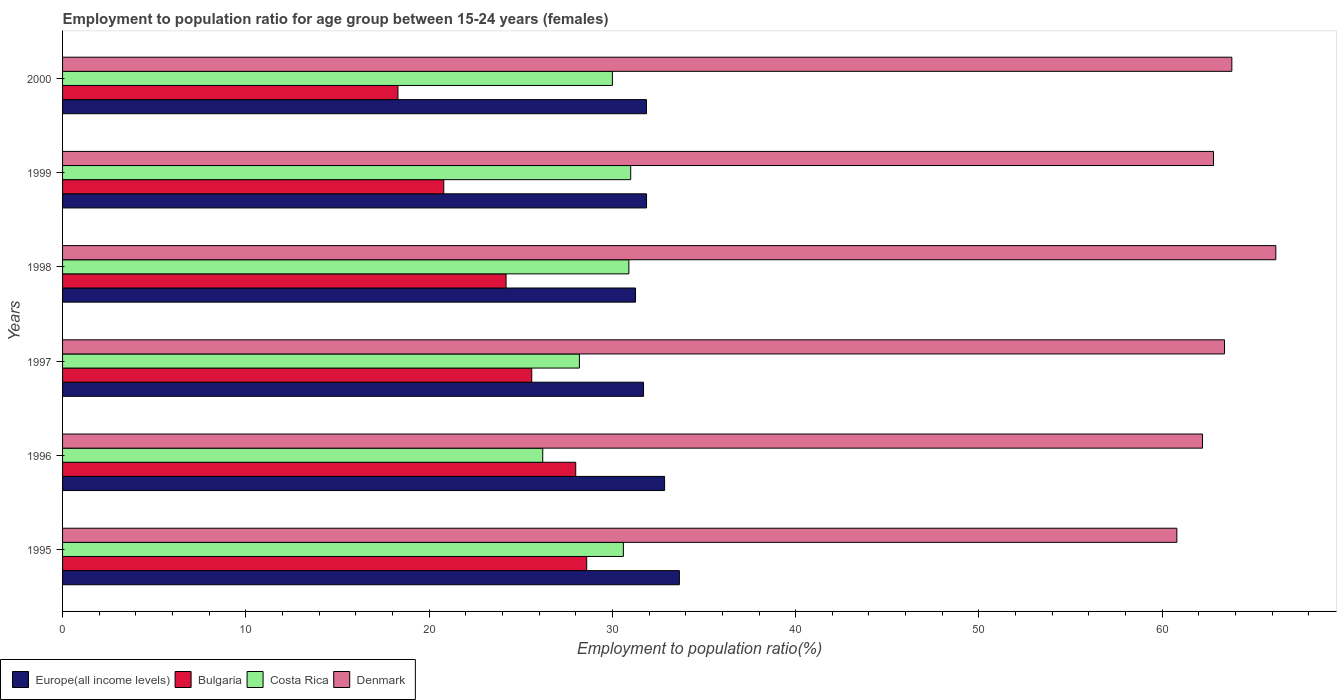How many different coloured bars are there?
Provide a short and direct response. 4. How many groups of bars are there?
Provide a succinct answer. 6. How many bars are there on the 5th tick from the top?
Your answer should be very brief. 4. How many bars are there on the 1st tick from the bottom?
Provide a succinct answer. 4. What is the label of the 2nd group of bars from the top?
Make the answer very short. 1999. In how many cases, is the number of bars for a given year not equal to the number of legend labels?
Your answer should be very brief. 0. What is the employment to population ratio in Bulgaria in 1999?
Offer a terse response. 20.8. Across all years, what is the maximum employment to population ratio in Denmark?
Ensure brevity in your answer.  66.2. Across all years, what is the minimum employment to population ratio in Europe(all income levels)?
Your answer should be compact. 31.26. In which year was the employment to population ratio in Bulgaria maximum?
Give a very brief answer. 1995. In which year was the employment to population ratio in Denmark minimum?
Keep it short and to the point. 1995. What is the total employment to population ratio in Denmark in the graph?
Your answer should be compact. 379.2. What is the difference between the employment to population ratio in Denmark in 1995 and that in 1997?
Give a very brief answer. -2.6. What is the difference between the employment to population ratio in Costa Rica in 1996 and the employment to population ratio in Denmark in 1999?
Give a very brief answer. -36.6. What is the average employment to population ratio in Bulgaria per year?
Your answer should be very brief. 24.25. In the year 1999, what is the difference between the employment to population ratio in Europe(all income levels) and employment to population ratio in Denmark?
Your response must be concise. -30.94. In how many years, is the employment to population ratio in Europe(all income levels) greater than 28 %?
Provide a succinct answer. 6. What is the ratio of the employment to population ratio in Bulgaria in 1995 to that in 2000?
Make the answer very short. 1.56. Is the employment to population ratio in Bulgaria in 1996 less than that in 1999?
Provide a succinct answer. No. Is the difference between the employment to population ratio in Europe(all income levels) in 1995 and 2000 greater than the difference between the employment to population ratio in Denmark in 1995 and 2000?
Your answer should be compact. Yes. What is the difference between the highest and the second highest employment to population ratio in Denmark?
Offer a very short reply. 2.4. What is the difference between the highest and the lowest employment to population ratio in Bulgaria?
Give a very brief answer. 10.3. In how many years, is the employment to population ratio in Europe(all income levels) greater than the average employment to population ratio in Europe(all income levels) taken over all years?
Give a very brief answer. 2. Is the sum of the employment to population ratio in Europe(all income levels) in 1996 and 1998 greater than the maximum employment to population ratio in Denmark across all years?
Provide a short and direct response. No. What does the 4th bar from the top in 1997 represents?
Provide a short and direct response. Europe(all income levels). What does the 1st bar from the bottom in 1995 represents?
Provide a succinct answer. Europe(all income levels). Is it the case that in every year, the sum of the employment to population ratio in Costa Rica and employment to population ratio in Europe(all income levels) is greater than the employment to population ratio in Denmark?
Offer a terse response. No. Are all the bars in the graph horizontal?
Give a very brief answer. Yes. How many years are there in the graph?
Make the answer very short. 6. Does the graph contain any zero values?
Offer a very short reply. No. Does the graph contain grids?
Your answer should be very brief. No. Where does the legend appear in the graph?
Provide a short and direct response. Bottom left. How are the legend labels stacked?
Make the answer very short. Horizontal. What is the title of the graph?
Provide a short and direct response. Employment to population ratio for age group between 15-24 years (females). Does "Sub-Saharan Africa (developing only)" appear as one of the legend labels in the graph?
Ensure brevity in your answer.  No. What is the label or title of the Y-axis?
Give a very brief answer. Years. What is the Employment to population ratio(%) of Europe(all income levels) in 1995?
Keep it short and to the point. 33.66. What is the Employment to population ratio(%) of Bulgaria in 1995?
Your answer should be compact. 28.6. What is the Employment to population ratio(%) of Costa Rica in 1995?
Offer a very short reply. 30.6. What is the Employment to population ratio(%) of Denmark in 1995?
Your answer should be very brief. 60.8. What is the Employment to population ratio(%) in Europe(all income levels) in 1996?
Keep it short and to the point. 32.85. What is the Employment to population ratio(%) in Costa Rica in 1996?
Your answer should be very brief. 26.2. What is the Employment to population ratio(%) of Denmark in 1996?
Keep it short and to the point. 62.2. What is the Employment to population ratio(%) in Europe(all income levels) in 1997?
Offer a very short reply. 31.7. What is the Employment to population ratio(%) in Bulgaria in 1997?
Your response must be concise. 25.6. What is the Employment to population ratio(%) of Costa Rica in 1997?
Give a very brief answer. 28.2. What is the Employment to population ratio(%) of Denmark in 1997?
Give a very brief answer. 63.4. What is the Employment to population ratio(%) of Europe(all income levels) in 1998?
Offer a very short reply. 31.26. What is the Employment to population ratio(%) in Bulgaria in 1998?
Provide a succinct answer. 24.2. What is the Employment to population ratio(%) in Costa Rica in 1998?
Provide a succinct answer. 30.9. What is the Employment to population ratio(%) in Denmark in 1998?
Provide a succinct answer. 66.2. What is the Employment to population ratio(%) of Europe(all income levels) in 1999?
Offer a terse response. 31.86. What is the Employment to population ratio(%) in Bulgaria in 1999?
Make the answer very short. 20.8. What is the Employment to population ratio(%) in Denmark in 1999?
Your response must be concise. 62.8. What is the Employment to population ratio(%) in Europe(all income levels) in 2000?
Provide a short and direct response. 31.86. What is the Employment to population ratio(%) of Bulgaria in 2000?
Provide a short and direct response. 18.3. What is the Employment to population ratio(%) in Denmark in 2000?
Ensure brevity in your answer.  63.8. Across all years, what is the maximum Employment to population ratio(%) of Europe(all income levels)?
Keep it short and to the point. 33.66. Across all years, what is the maximum Employment to population ratio(%) of Bulgaria?
Make the answer very short. 28.6. Across all years, what is the maximum Employment to population ratio(%) of Costa Rica?
Provide a succinct answer. 31. Across all years, what is the maximum Employment to population ratio(%) in Denmark?
Provide a succinct answer. 66.2. Across all years, what is the minimum Employment to population ratio(%) of Europe(all income levels)?
Your answer should be compact. 31.26. Across all years, what is the minimum Employment to population ratio(%) of Bulgaria?
Give a very brief answer. 18.3. Across all years, what is the minimum Employment to population ratio(%) of Costa Rica?
Offer a terse response. 26.2. Across all years, what is the minimum Employment to population ratio(%) in Denmark?
Your answer should be very brief. 60.8. What is the total Employment to population ratio(%) in Europe(all income levels) in the graph?
Ensure brevity in your answer.  193.19. What is the total Employment to population ratio(%) in Bulgaria in the graph?
Give a very brief answer. 145.5. What is the total Employment to population ratio(%) in Costa Rica in the graph?
Give a very brief answer. 176.9. What is the total Employment to population ratio(%) of Denmark in the graph?
Offer a terse response. 379.2. What is the difference between the Employment to population ratio(%) in Europe(all income levels) in 1995 and that in 1996?
Keep it short and to the point. 0.81. What is the difference between the Employment to population ratio(%) of Costa Rica in 1995 and that in 1996?
Make the answer very short. 4.4. What is the difference between the Employment to population ratio(%) of Europe(all income levels) in 1995 and that in 1997?
Provide a succinct answer. 1.96. What is the difference between the Employment to population ratio(%) in Bulgaria in 1995 and that in 1997?
Your answer should be compact. 3. What is the difference between the Employment to population ratio(%) of Costa Rica in 1995 and that in 1997?
Your answer should be very brief. 2.4. What is the difference between the Employment to population ratio(%) in Europe(all income levels) in 1995 and that in 1998?
Ensure brevity in your answer.  2.39. What is the difference between the Employment to population ratio(%) in Bulgaria in 1995 and that in 1998?
Offer a terse response. 4.4. What is the difference between the Employment to population ratio(%) in Costa Rica in 1995 and that in 1998?
Make the answer very short. -0.3. What is the difference between the Employment to population ratio(%) in Europe(all income levels) in 1995 and that in 1999?
Keep it short and to the point. 1.79. What is the difference between the Employment to population ratio(%) of Bulgaria in 1995 and that in 1999?
Your response must be concise. 7.8. What is the difference between the Employment to population ratio(%) in Costa Rica in 1995 and that in 1999?
Ensure brevity in your answer.  -0.4. What is the difference between the Employment to population ratio(%) in Europe(all income levels) in 1995 and that in 2000?
Make the answer very short. 1.8. What is the difference between the Employment to population ratio(%) of Bulgaria in 1995 and that in 2000?
Give a very brief answer. 10.3. What is the difference between the Employment to population ratio(%) of Denmark in 1995 and that in 2000?
Ensure brevity in your answer.  -3. What is the difference between the Employment to population ratio(%) in Europe(all income levels) in 1996 and that in 1997?
Your answer should be very brief. 1.15. What is the difference between the Employment to population ratio(%) of Europe(all income levels) in 1996 and that in 1998?
Keep it short and to the point. 1.59. What is the difference between the Employment to population ratio(%) of Bulgaria in 1996 and that in 1998?
Your answer should be very brief. 3.8. What is the difference between the Employment to population ratio(%) of Denmark in 1996 and that in 1998?
Your answer should be compact. -4. What is the difference between the Employment to population ratio(%) in Europe(all income levels) in 1996 and that in 1999?
Ensure brevity in your answer.  0.98. What is the difference between the Employment to population ratio(%) of Bulgaria in 1996 and that in 1999?
Ensure brevity in your answer.  7.2. What is the difference between the Employment to population ratio(%) of Costa Rica in 1996 and that in 1999?
Your answer should be compact. -4.8. What is the difference between the Employment to population ratio(%) in Europe(all income levels) in 1996 and that in 2000?
Ensure brevity in your answer.  0.99. What is the difference between the Employment to population ratio(%) in Europe(all income levels) in 1997 and that in 1998?
Keep it short and to the point. 0.44. What is the difference between the Employment to population ratio(%) of Europe(all income levels) in 1997 and that in 1999?
Offer a very short reply. -0.17. What is the difference between the Employment to population ratio(%) in Bulgaria in 1997 and that in 1999?
Your response must be concise. 4.8. What is the difference between the Employment to population ratio(%) of Costa Rica in 1997 and that in 1999?
Your response must be concise. -2.8. What is the difference between the Employment to population ratio(%) of Denmark in 1997 and that in 1999?
Provide a succinct answer. 0.6. What is the difference between the Employment to population ratio(%) of Europe(all income levels) in 1997 and that in 2000?
Make the answer very short. -0.16. What is the difference between the Employment to population ratio(%) of Costa Rica in 1997 and that in 2000?
Ensure brevity in your answer.  -1.8. What is the difference between the Employment to population ratio(%) in Europe(all income levels) in 1998 and that in 1999?
Give a very brief answer. -0.6. What is the difference between the Employment to population ratio(%) of Bulgaria in 1998 and that in 1999?
Provide a succinct answer. 3.4. What is the difference between the Employment to population ratio(%) of Denmark in 1998 and that in 1999?
Your response must be concise. 3.4. What is the difference between the Employment to population ratio(%) of Europe(all income levels) in 1998 and that in 2000?
Ensure brevity in your answer.  -0.6. What is the difference between the Employment to population ratio(%) of Bulgaria in 1998 and that in 2000?
Ensure brevity in your answer.  5.9. What is the difference between the Employment to population ratio(%) of Costa Rica in 1998 and that in 2000?
Offer a very short reply. 0.9. What is the difference between the Employment to population ratio(%) in Denmark in 1998 and that in 2000?
Ensure brevity in your answer.  2.4. What is the difference between the Employment to population ratio(%) of Europe(all income levels) in 1999 and that in 2000?
Your response must be concise. 0. What is the difference between the Employment to population ratio(%) of Bulgaria in 1999 and that in 2000?
Offer a very short reply. 2.5. What is the difference between the Employment to population ratio(%) of Costa Rica in 1999 and that in 2000?
Offer a very short reply. 1. What is the difference between the Employment to population ratio(%) of Denmark in 1999 and that in 2000?
Make the answer very short. -1. What is the difference between the Employment to population ratio(%) in Europe(all income levels) in 1995 and the Employment to population ratio(%) in Bulgaria in 1996?
Your response must be concise. 5.66. What is the difference between the Employment to population ratio(%) in Europe(all income levels) in 1995 and the Employment to population ratio(%) in Costa Rica in 1996?
Your response must be concise. 7.46. What is the difference between the Employment to population ratio(%) of Europe(all income levels) in 1995 and the Employment to population ratio(%) of Denmark in 1996?
Give a very brief answer. -28.55. What is the difference between the Employment to population ratio(%) in Bulgaria in 1995 and the Employment to population ratio(%) in Denmark in 1996?
Keep it short and to the point. -33.6. What is the difference between the Employment to population ratio(%) in Costa Rica in 1995 and the Employment to population ratio(%) in Denmark in 1996?
Your response must be concise. -31.6. What is the difference between the Employment to population ratio(%) in Europe(all income levels) in 1995 and the Employment to population ratio(%) in Bulgaria in 1997?
Your answer should be very brief. 8.05. What is the difference between the Employment to population ratio(%) in Europe(all income levels) in 1995 and the Employment to population ratio(%) in Costa Rica in 1997?
Your answer should be compact. 5.46. What is the difference between the Employment to population ratio(%) of Europe(all income levels) in 1995 and the Employment to population ratio(%) of Denmark in 1997?
Keep it short and to the point. -29.75. What is the difference between the Employment to population ratio(%) of Bulgaria in 1995 and the Employment to population ratio(%) of Denmark in 1997?
Offer a terse response. -34.8. What is the difference between the Employment to population ratio(%) in Costa Rica in 1995 and the Employment to population ratio(%) in Denmark in 1997?
Offer a very short reply. -32.8. What is the difference between the Employment to population ratio(%) of Europe(all income levels) in 1995 and the Employment to population ratio(%) of Bulgaria in 1998?
Your response must be concise. 9.46. What is the difference between the Employment to population ratio(%) in Europe(all income levels) in 1995 and the Employment to population ratio(%) in Costa Rica in 1998?
Keep it short and to the point. 2.75. What is the difference between the Employment to population ratio(%) in Europe(all income levels) in 1995 and the Employment to population ratio(%) in Denmark in 1998?
Give a very brief answer. -32.55. What is the difference between the Employment to population ratio(%) of Bulgaria in 1995 and the Employment to population ratio(%) of Costa Rica in 1998?
Offer a terse response. -2.3. What is the difference between the Employment to population ratio(%) in Bulgaria in 1995 and the Employment to population ratio(%) in Denmark in 1998?
Ensure brevity in your answer.  -37.6. What is the difference between the Employment to population ratio(%) of Costa Rica in 1995 and the Employment to population ratio(%) of Denmark in 1998?
Offer a terse response. -35.6. What is the difference between the Employment to population ratio(%) in Europe(all income levels) in 1995 and the Employment to population ratio(%) in Bulgaria in 1999?
Give a very brief answer. 12.86. What is the difference between the Employment to population ratio(%) in Europe(all income levels) in 1995 and the Employment to population ratio(%) in Costa Rica in 1999?
Your answer should be very brief. 2.65. What is the difference between the Employment to population ratio(%) in Europe(all income levels) in 1995 and the Employment to population ratio(%) in Denmark in 1999?
Provide a short and direct response. -29.14. What is the difference between the Employment to population ratio(%) in Bulgaria in 1995 and the Employment to population ratio(%) in Denmark in 1999?
Ensure brevity in your answer.  -34.2. What is the difference between the Employment to population ratio(%) of Costa Rica in 1995 and the Employment to population ratio(%) of Denmark in 1999?
Your answer should be very brief. -32.2. What is the difference between the Employment to population ratio(%) in Europe(all income levels) in 1995 and the Employment to population ratio(%) in Bulgaria in 2000?
Keep it short and to the point. 15.36. What is the difference between the Employment to population ratio(%) of Europe(all income levels) in 1995 and the Employment to population ratio(%) of Costa Rica in 2000?
Your response must be concise. 3.65. What is the difference between the Employment to population ratio(%) of Europe(all income levels) in 1995 and the Employment to population ratio(%) of Denmark in 2000?
Make the answer very short. -30.14. What is the difference between the Employment to population ratio(%) in Bulgaria in 1995 and the Employment to population ratio(%) in Denmark in 2000?
Ensure brevity in your answer.  -35.2. What is the difference between the Employment to population ratio(%) of Costa Rica in 1995 and the Employment to population ratio(%) of Denmark in 2000?
Your answer should be compact. -33.2. What is the difference between the Employment to population ratio(%) of Europe(all income levels) in 1996 and the Employment to population ratio(%) of Bulgaria in 1997?
Give a very brief answer. 7.25. What is the difference between the Employment to population ratio(%) of Europe(all income levels) in 1996 and the Employment to population ratio(%) of Costa Rica in 1997?
Your answer should be compact. 4.65. What is the difference between the Employment to population ratio(%) of Europe(all income levels) in 1996 and the Employment to population ratio(%) of Denmark in 1997?
Your response must be concise. -30.55. What is the difference between the Employment to population ratio(%) of Bulgaria in 1996 and the Employment to population ratio(%) of Costa Rica in 1997?
Keep it short and to the point. -0.2. What is the difference between the Employment to population ratio(%) in Bulgaria in 1996 and the Employment to population ratio(%) in Denmark in 1997?
Make the answer very short. -35.4. What is the difference between the Employment to population ratio(%) of Costa Rica in 1996 and the Employment to population ratio(%) of Denmark in 1997?
Give a very brief answer. -37.2. What is the difference between the Employment to population ratio(%) in Europe(all income levels) in 1996 and the Employment to population ratio(%) in Bulgaria in 1998?
Make the answer very short. 8.65. What is the difference between the Employment to population ratio(%) of Europe(all income levels) in 1996 and the Employment to population ratio(%) of Costa Rica in 1998?
Your response must be concise. 1.95. What is the difference between the Employment to population ratio(%) of Europe(all income levels) in 1996 and the Employment to population ratio(%) of Denmark in 1998?
Provide a succinct answer. -33.35. What is the difference between the Employment to population ratio(%) of Bulgaria in 1996 and the Employment to population ratio(%) of Costa Rica in 1998?
Your response must be concise. -2.9. What is the difference between the Employment to population ratio(%) in Bulgaria in 1996 and the Employment to population ratio(%) in Denmark in 1998?
Provide a short and direct response. -38.2. What is the difference between the Employment to population ratio(%) in Europe(all income levels) in 1996 and the Employment to population ratio(%) in Bulgaria in 1999?
Offer a very short reply. 12.05. What is the difference between the Employment to population ratio(%) of Europe(all income levels) in 1996 and the Employment to population ratio(%) of Costa Rica in 1999?
Offer a terse response. 1.85. What is the difference between the Employment to population ratio(%) in Europe(all income levels) in 1996 and the Employment to population ratio(%) in Denmark in 1999?
Offer a very short reply. -29.95. What is the difference between the Employment to population ratio(%) of Bulgaria in 1996 and the Employment to population ratio(%) of Costa Rica in 1999?
Keep it short and to the point. -3. What is the difference between the Employment to population ratio(%) in Bulgaria in 1996 and the Employment to population ratio(%) in Denmark in 1999?
Ensure brevity in your answer.  -34.8. What is the difference between the Employment to population ratio(%) of Costa Rica in 1996 and the Employment to population ratio(%) of Denmark in 1999?
Your response must be concise. -36.6. What is the difference between the Employment to population ratio(%) of Europe(all income levels) in 1996 and the Employment to population ratio(%) of Bulgaria in 2000?
Your response must be concise. 14.55. What is the difference between the Employment to population ratio(%) in Europe(all income levels) in 1996 and the Employment to population ratio(%) in Costa Rica in 2000?
Provide a succinct answer. 2.85. What is the difference between the Employment to population ratio(%) in Europe(all income levels) in 1996 and the Employment to population ratio(%) in Denmark in 2000?
Your response must be concise. -30.95. What is the difference between the Employment to population ratio(%) in Bulgaria in 1996 and the Employment to population ratio(%) in Denmark in 2000?
Your answer should be compact. -35.8. What is the difference between the Employment to population ratio(%) of Costa Rica in 1996 and the Employment to population ratio(%) of Denmark in 2000?
Make the answer very short. -37.6. What is the difference between the Employment to population ratio(%) in Europe(all income levels) in 1997 and the Employment to population ratio(%) in Bulgaria in 1998?
Provide a succinct answer. 7.5. What is the difference between the Employment to population ratio(%) of Europe(all income levels) in 1997 and the Employment to population ratio(%) of Costa Rica in 1998?
Offer a terse response. 0.8. What is the difference between the Employment to population ratio(%) in Europe(all income levels) in 1997 and the Employment to population ratio(%) in Denmark in 1998?
Give a very brief answer. -34.5. What is the difference between the Employment to population ratio(%) of Bulgaria in 1997 and the Employment to population ratio(%) of Costa Rica in 1998?
Ensure brevity in your answer.  -5.3. What is the difference between the Employment to population ratio(%) of Bulgaria in 1997 and the Employment to population ratio(%) of Denmark in 1998?
Offer a very short reply. -40.6. What is the difference between the Employment to population ratio(%) in Costa Rica in 1997 and the Employment to population ratio(%) in Denmark in 1998?
Offer a very short reply. -38. What is the difference between the Employment to population ratio(%) of Europe(all income levels) in 1997 and the Employment to population ratio(%) of Bulgaria in 1999?
Give a very brief answer. 10.9. What is the difference between the Employment to population ratio(%) in Europe(all income levels) in 1997 and the Employment to population ratio(%) in Costa Rica in 1999?
Provide a succinct answer. 0.7. What is the difference between the Employment to population ratio(%) in Europe(all income levels) in 1997 and the Employment to population ratio(%) in Denmark in 1999?
Your answer should be very brief. -31.1. What is the difference between the Employment to population ratio(%) in Bulgaria in 1997 and the Employment to population ratio(%) in Costa Rica in 1999?
Make the answer very short. -5.4. What is the difference between the Employment to population ratio(%) of Bulgaria in 1997 and the Employment to population ratio(%) of Denmark in 1999?
Keep it short and to the point. -37.2. What is the difference between the Employment to population ratio(%) of Costa Rica in 1997 and the Employment to population ratio(%) of Denmark in 1999?
Provide a short and direct response. -34.6. What is the difference between the Employment to population ratio(%) of Europe(all income levels) in 1997 and the Employment to population ratio(%) of Bulgaria in 2000?
Offer a terse response. 13.4. What is the difference between the Employment to population ratio(%) in Europe(all income levels) in 1997 and the Employment to population ratio(%) in Costa Rica in 2000?
Your answer should be very brief. 1.7. What is the difference between the Employment to population ratio(%) of Europe(all income levels) in 1997 and the Employment to population ratio(%) of Denmark in 2000?
Offer a terse response. -32.1. What is the difference between the Employment to population ratio(%) of Bulgaria in 1997 and the Employment to population ratio(%) of Costa Rica in 2000?
Offer a very short reply. -4.4. What is the difference between the Employment to population ratio(%) of Bulgaria in 1997 and the Employment to population ratio(%) of Denmark in 2000?
Make the answer very short. -38.2. What is the difference between the Employment to population ratio(%) of Costa Rica in 1997 and the Employment to population ratio(%) of Denmark in 2000?
Provide a succinct answer. -35.6. What is the difference between the Employment to population ratio(%) in Europe(all income levels) in 1998 and the Employment to population ratio(%) in Bulgaria in 1999?
Keep it short and to the point. 10.46. What is the difference between the Employment to population ratio(%) in Europe(all income levels) in 1998 and the Employment to population ratio(%) in Costa Rica in 1999?
Your answer should be compact. 0.26. What is the difference between the Employment to population ratio(%) in Europe(all income levels) in 1998 and the Employment to population ratio(%) in Denmark in 1999?
Keep it short and to the point. -31.54. What is the difference between the Employment to population ratio(%) in Bulgaria in 1998 and the Employment to population ratio(%) in Denmark in 1999?
Your response must be concise. -38.6. What is the difference between the Employment to population ratio(%) in Costa Rica in 1998 and the Employment to population ratio(%) in Denmark in 1999?
Your response must be concise. -31.9. What is the difference between the Employment to population ratio(%) of Europe(all income levels) in 1998 and the Employment to population ratio(%) of Bulgaria in 2000?
Ensure brevity in your answer.  12.96. What is the difference between the Employment to population ratio(%) in Europe(all income levels) in 1998 and the Employment to population ratio(%) in Costa Rica in 2000?
Offer a very short reply. 1.26. What is the difference between the Employment to population ratio(%) of Europe(all income levels) in 1998 and the Employment to population ratio(%) of Denmark in 2000?
Offer a very short reply. -32.54. What is the difference between the Employment to population ratio(%) in Bulgaria in 1998 and the Employment to population ratio(%) in Denmark in 2000?
Your answer should be compact. -39.6. What is the difference between the Employment to population ratio(%) of Costa Rica in 1998 and the Employment to population ratio(%) of Denmark in 2000?
Your response must be concise. -32.9. What is the difference between the Employment to population ratio(%) of Europe(all income levels) in 1999 and the Employment to population ratio(%) of Bulgaria in 2000?
Your answer should be very brief. 13.56. What is the difference between the Employment to population ratio(%) in Europe(all income levels) in 1999 and the Employment to population ratio(%) in Costa Rica in 2000?
Provide a succinct answer. 1.86. What is the difference between the Employment to population ratio(%) of Europe(all income levels) in 1999 and the Employment to population ratio(%) of Denmark in 2000?
Your answer should be compact. -31.94. What is the difference between the Employment to population ratio(%) in Bulgaria in 1999 and the Employment to population ratio(%) in Costa Rica in 2000?
Ensure brevity in your answer.  -9.2. What is the difference between the Employment to population ratio(%) in Bulgaria in 1999 and the Employment to population ratio(%) in Denmark in 2000?
Your response must be concise. -43. What is the difference between the Employment to population ratio(%) in Costa Rica in 1999 and the Employment to population ratio(%) in Denmark in 2000?
Make the answer very short. -32.8. What is the average Employment to population ratio(%) in Europe(all income levels) per year?
Give a very brief answer. 32.2. What is the average Employment to population ratio(%) of Bulgaria per year?
Give a very brief answer. 24.25. What is the average Employment to population ratio(%) in Costa Rica per year?
Your response must be concise. 29.48. What is the average Employment to population ratio(%) of Denmark per year?
Provide a succinct answer. 63.2. In the year 1995, what is the difference between the Employment to population ratio(%) in Europe(all income levels) and Employment to population ratio(%) in Bulgaria?
Keep it short and to the point. 5.05. In the year 1995, what is the difference between the Employment to population ratio(%) in Europe(all income levels) and Employment to population ratio(%) in Costa Rica?
Provide a succinct answer. 3.06. In the year 1995, what is the difference between the Employment to population ratio(%) in Europe(all income levels) and Employment to population ratio(%) in Denmark?
Keep it short and to the point. -27.14. In the year 1995, what is the difference between the Employment to population ratio(%) in Bulgaria and Employment to population ratio(%) in Costa Rica?
Offer a terse response. -2. In the year 1995, what is the difference between the Employment to population ratio(%) of Bulgaria and Employment to population ratio(%) of Denmark?
Offer a terse response. -32.2. In the year 1995, what is the difference between the Employment to population ratio(%) of Costa Rica and Employment to population ratio(%) of Denmark?
Keep it short and to the point. -30.2. In the year 1996, what is the difference between the Employment to population ratio(%) of Europe(all income levels) and Employment to population ratio(%) of Bulgaria?
Your response must be concise. 4.85. In the year 1996, what is the difference between the Employment to population ratio(%) of Europe(all income levels) and Employment to population ratio(%) of Costa Rica?
Make the answer very short. 6.65. In the year 1996, what is the difference between the Employment to population ratio(%) in Europe(all income levels) and Employment to population ratio(%) in Denmark?
Provide a short and direct response. -29.35. In the year 1996, what is the difference between the Employment to population ratio(%) of Bulgaria and Employment to population ratio(%) of Denmark?
Make the answer very short. -34.2. In the year 1996, what is the difference between the Employment to population ratio(%) in Costa Rica and Employment to population ratio(%) in Denmark?
Your answer should be compact. -36. In the year 1997, what is the difference between the Employment to population ratio(%) of Europe(all income levels) and Employment to population ratio(%) of Bulgaria?
Provide a short and direct response. 6.1. In the year 1997, what is the difference between the Employment to population ratio(%) of Europe(all income levels) and Employment to population ratio(%) of Costa Rica?
Provide a short and direct response. 3.5. In the year 1997, what is the difference between the Employment to population ratio(%) in Europe(all income levels) and Employment to population ratio(%) in Denmark?
Provide a succinct answer. -31.7. In the year 1997, what is the difference between the Employment to population ratio(%) of Bulgaria and Employment to population ratio(%) of Denmark?
Provide a succinct answer. -37.8. In the year 1997, what is the difference between the Employment to population ratio(%) in Costa Rica and Employment to population ratio(%) in Denmark?
Your answer should be compact. -35.2. In the year 1998, what is the difference between the Employment to population ratio(%) in Europe(all income levels) and Employment to population ratio(%) in Bulgaria?
Give a very brief answer. 7.06. In the year 1998, what is the difference between the Employment to population ratio(%) in Europe(all income levels) and Employment to population ratio(%) in Costa Rica?
Ensure brevity in your answer.  0.36. In the year 1998, what is the difference between the Employment to population ratio(%) in Europe(all income levels) and Employment to population ratio(%) in Denmark?
Make the answer very short. -34.94. In the year 1998, what is the difference between the Employment to population ratio(%) of Bulgaria and Employment to population ratio(%) of Costa Rica?
Offer a very short reply. -6.7. In the year 1998, what is the difference between the Employment to population ratio(%) of Bulgaria and Employment to population ratio(%) of Denmark?
Your response must be concise. -42. In the year 1998, what is the difference between the Employment to population ratio(%) in Costa Rica and Employment to population ratio(%) in Denmark?
Ensure brevity in your answer.  -35.3. In the year 1999, what is the difference between the Employment to population ratio(%) in Europe(all income levels) and Employment to population ratio(%) in Bulgaria?
Ensure brevity in your answer.  11.06. In the year 1999, what is the difference between the Employment to population ratio(%) of Europe(all income levels) and Employment to population ratio(%) of Costa Rica?
Offer a terse response. 0.86. In the year 1999, what is the difference between the Employment to population ratio(%) of Europe(all income levels) and Employment to population ratio(%) of Denmark?
Your response must be concise. -30.94. In the year 1999, what is the difference between the Employment to population ratio(%) of Bulgaria and Employment to population ratio(%) of Costa Rica?
Keep it short and to the point. -10.2. In the year 1999, what is the difference between the Employment to population ratio(%) of Bulgaria and Employment to population ratio(%) of Denmark?
Make the answer very short. -42. In the year 1999, what is the difference between the Employment to population ratio(%) in Costa Rica and Employment to population ratio(%) in Denmark?
Your answer should be compact. -31.8. In the year 2000, what is the difference between the Employment to population ratio(%) of Europe(all income levels) and Employment to population ratio(%) of Bulgaria?
Your answer should be compact. 13.56. In the year 2000, what is the difference between the Employment to population ratio(%) of Europe(all income levels) and Employment to population ratio(%) of Costa Rica?
Your answer should be compact. 1.86. In the year 2000, what is the difference between the Employment to population ratio(%) in Europe(all income levels) and Employment to population ratio(%) in Denmark?
Make the answer very short. -31.94. In the year 2000, what is the difference between the Employment to population ratio(%) in Bulgaria and Employment to population ratio(%) in Denmark?
Your answer should be compact. -45.5. In the year 2000, what is the difference between the Employment to population ratio(%) in Costa Rica and Employment to population ratio(%) in Denmark?
Your response must be concise. -33.8. What is the ratio of the Employment to population ratio(%) of Europe(all income levels) in 1995 to that in 1996?
Make the answer very short. 1.02. What is the ratio of the Employment to population ratio(%) of Bulgaria in 1995 to that in 1996?
Your answer should be compact. 1.02. What is the ratio of the Employment to population ratio(%) of Costa Rica in 1995 to that in 1996?
Make the answer very short. 1.17. What is the ratio of the Employment to population ratio(%) of Denmark in 1995 to that in 1996?
Your response must be concise. 0.98. What is the ratio of the Employment to population ratio(%) of Europe(all income levels) in 1995 to that in 1997?
Offer a very short reply. 1.06. What is the ratio of the Employment to population ratio(%) of Bulgaria in 1995 to that in 1997?
Offer a very short reply. 1.12. What is the ratio of the Employment to population ratio(%) in Costa Rica in 1995 to that in 1997?
Provide a short and direct response. 1.09. What is the ratio of the Employment to population ratio(%) of Denmark in 1995 to that in 1997?
Offer a terse response. 0.96. What is the ratio of the Employment to population ratio(%) in Europe(all income levels) in 1995 to that in 1998?
Your answer should be compact. 1.08. What is the ratio of the Employment to population ratio(%) of Bulgaria in 1995 to that in 1998?
Your answer should be very brief. 1.18. What is the ratio of the Employment to population ratio(%) of Costa Rica in 1995 to that in 1998?
Offer a very short reply. 0.99. What is the ratio of the Employment to population ratio(%) of Denmark in 1995 to that in 1998?
Make the answer very short. 0.92. What is the ratio of the Employment to population ratio(%) in Europe(all income levels) in 1995 to that in 1999?
Your answer should be compact. 1.06. What is the ratio of the Employment to population ratio(%) of Bulgaria in 1995 to that in 1999?
Provide a succinct answer. 1.38. What is the ratio of the Employment to population ratio(%) of Costa Rica in 1995 to that in 1999?
Your response must be concise. 0.99. What is the ratio of the Employment to population ratio(%) in Denmark in 1995 to that in 1999?
Provide a short and direct response. 0.97. What is the ratio of the Employment to population ratio(%) in Europe(all income levels) in 1995 to that in 2000?
Your response must be concise. 1.06. What is the ratio of the Employment to population ratio(%) of Bulgaria in 1995 to that in 2000?
Provide a succinct answer. 1.56. What is the ratio of the Employment to population ratio(%) in Denmark in 1995 to that in 2000?
Give a very brief answer. 0.95. What is the ratio of the Employment to population ratio(%) in Europe(all income levels) in 1996 to that in 1997?
Ensure brevity in your answer.  1.04. What is the ratio of the Employment to population ratio(%) of Bulgaria in 1996 to that in 1997?
Provide a short and direct response. 1.09. What is the ratio of the Employment to population ratio(%) of Costa Rica in 1996 to that in 1997?
Keep it short and to the point. 0.93. What is the ratio of the Employment to population ratio(%) in Denmark in 1996 to that in 1997?
Your response must be concise. 0.98. What is the ratio of the Employment to population ratio(%) in Europe(all income levels) in 1996 to that in 1998?
Give a very brief answer. 1.05. What is the ratio of the Employment to population ratio(%) in Bulgaria in 1996 to that in 1998?
Your response must be concise. 1.16. What is the ratio of the Employment to population ratio(%) in Costa Rica in 1996 to that in 1998?
Your response must be concise. 0.85. What is the ratio of the Employment to population ratio(%) in Denmark in 1996 to that in 1998?
Offer a very short reply. 0.94. What is the ratio of the Employment to population ratio(%) of Europe(all income levels) in 1996 to that in 1999?
Offer a very short reply. 1.03. What is the ratio of the Employment to population ratio(%) of Bulgaria in 1996 to that in 1999?
Your answer should be very brief. 1.35. What is the ratio of the Employment to population ratio(%) of Costa Rica in 1996 to that in 1999?
Your answer should be very brief. 0.85. What is the ratio of the Employment to population ratio(%) of Europe(all income levels) in 1996 to that in 2000?
Ensure brevity in your answer.  1.03. What is the ratio of the Employment to population ratio(%) of Bulgaria in 1996 to that in 2000?
Keep it short and to the point. 1.53. What is the ratio of the Employment to population ratio(%) of Costa Rica in 1996 to that in 2000?
Your answer should be very brief. 0.87. What is the ratio of the Employment to population ratio(%) in Denmark in 1996 to that in 2000?
Offer a very short reply. 0.97. What is the ratio of the Employment to population ratio(%) of Bulgaria in 1997 to that in 1998?
Ensure brevity in your answer.  1.06. What is the ratio of the Employment to population ratio(%) in Costa Rica in 1997 to that in 1998?
Provide a succinct answer. 0.91. What is the ratio of the Employment to population ratio(%) of Denmark in 1997 to that in 1998?
Offer a terse response. 0.96. What is the ratio of the Employment to population ratio(%) of Europe(all income levels) in 1997 to that in 1999?
Offer a terse response. 0.99. What is the ratio of the Employment to population ratio(%) of Bulgaria in 1997 to that in 1999?
Provide a succinct answer. 1.23. What is the ratio of the Employment to population ratio(%) in Costa Rica in 1997 to that in 1999?
Ensure brevity in your answer.  0.91. What is the ratio of the Employment to population ratio(%) of Denmark in 1997 to that in 1999?
Give a very brief answer. 1.01. What is the ratio of the Employment to population ratio(%) of Bulgaria in 1997 to that in 2000?
Keep it short and to the point. 1.4. What is the ratio of the Employment to population ratio(%) in Costa Rica in 1997 to that in 2000?
Your answer should be very brief. 0.94. What is the ratio of the Employment to population ratio(%) of Denmark in 1997 to that in 2000?
Offer a very short reply. 0.99. What is the ratio of the Employment to population ratio(%) in Europe(all income levels) in 1998 to that in 1999?
Offer a very short reply. 0.98. What is the ratio of the Employment to population ratio(%) of Bulgaria in 1998 to that in 1999?
Keep it short and to the point. 1.16. What is the ratio of the Employment to population ratio(%) of Costa Rica in 1998 to that in 1999?
Make the answer very short. 1. What is the ratio of the Employment to population ratio(%) in Denmark in 1998 to that in 1999?
Keep it short and to the point. 1.05. What is the ratio of the Employment to population ratio(%) in Europe(all income levels) in 1998 to that in 2000?
Offer a very short reply. 0.98. What is the ratio of the Employment to population ratio(%) in Bulgaria in 1998 to that in 2000?
Ensure brevity in your answer.  1.32. What is the ratio of the Employment to population ratio(%) of Denmark in 1998 to that in 2000?
Your response must be concise. 1.04. What is the ratio of the Employment to population ratio(%) of Bulgaria in 1999 to that in 2000?
Provide a succinct answer. 1.14. What is the ratio of the Employment to population ratio(%) of Denmark in 1999 to that in 2000?
Offer a very short reply. 0.98. What is the difference between the highest and the second highest Employment to population ratio(%) in Europe(all income levels)?
Offer a very short reply. 0.81. What is the difference between the highest and the second highest Employment to population ratio(%) of Bulgaria?
Offer a terse response. 0.6. What is the difference between the highest and the second highest Employment to population ratio(%) in Denmark?
Provide a succinct answer. 2.4. What is the difference between the highest and the lowest Employment to population ratio(%) in Europe(all income levels)?
Your response must be concise. 2.39. What is the difference between the highest and the lowest Employment to population ratio(%) of Denmark?
Make the answer very short. 5.4. 